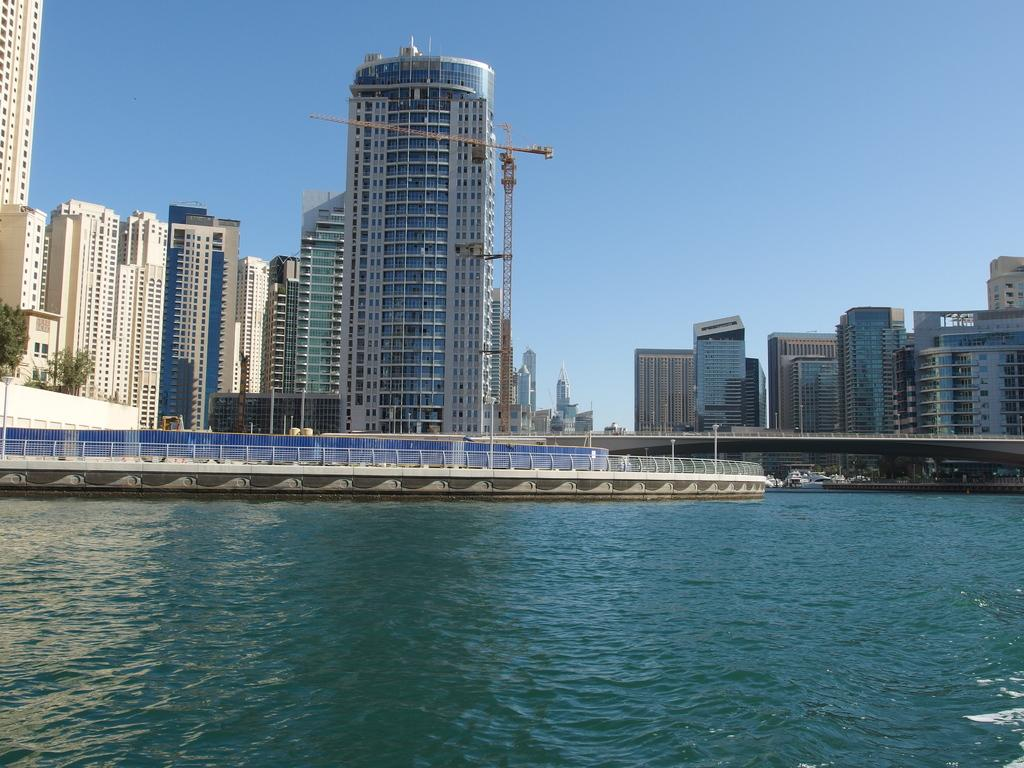What type of location is depicted in the image? The image shows an outside view. What natural feature can be seen beside the buildings? There is a sea beside some buildings in the image. What part of the natural environment is visible in the background? The sky is visible in the background of the image. How many ladybugs can be seen on the crown in the image? There is no crown or ladybugs present in the image. 